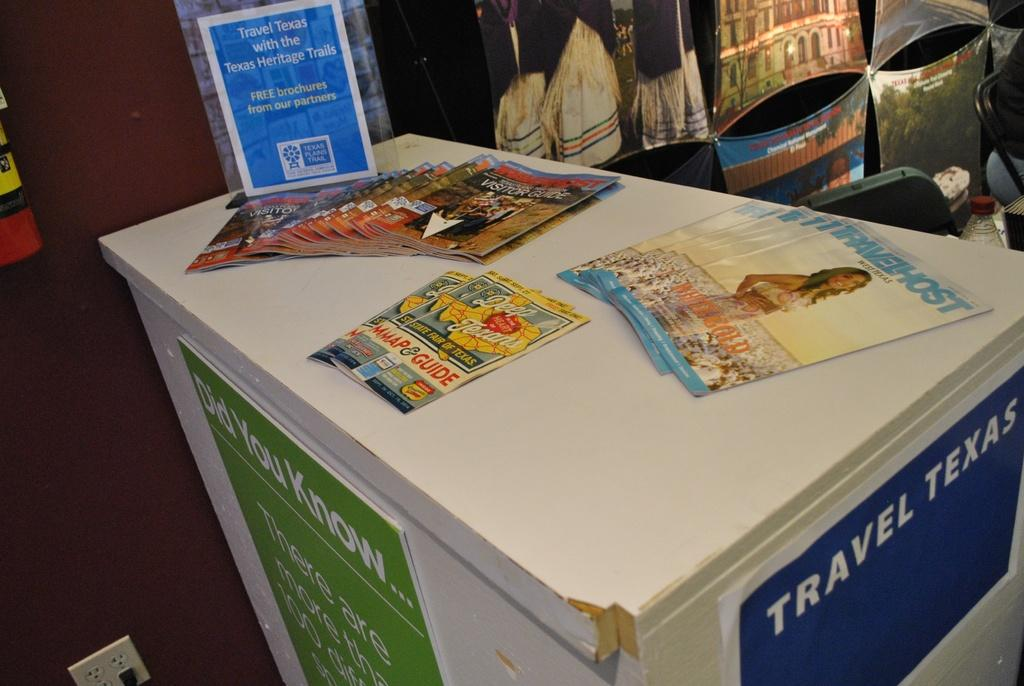<image>
Share a concise interpretation of the image provided. A white box reads Travel Texas on one side. 